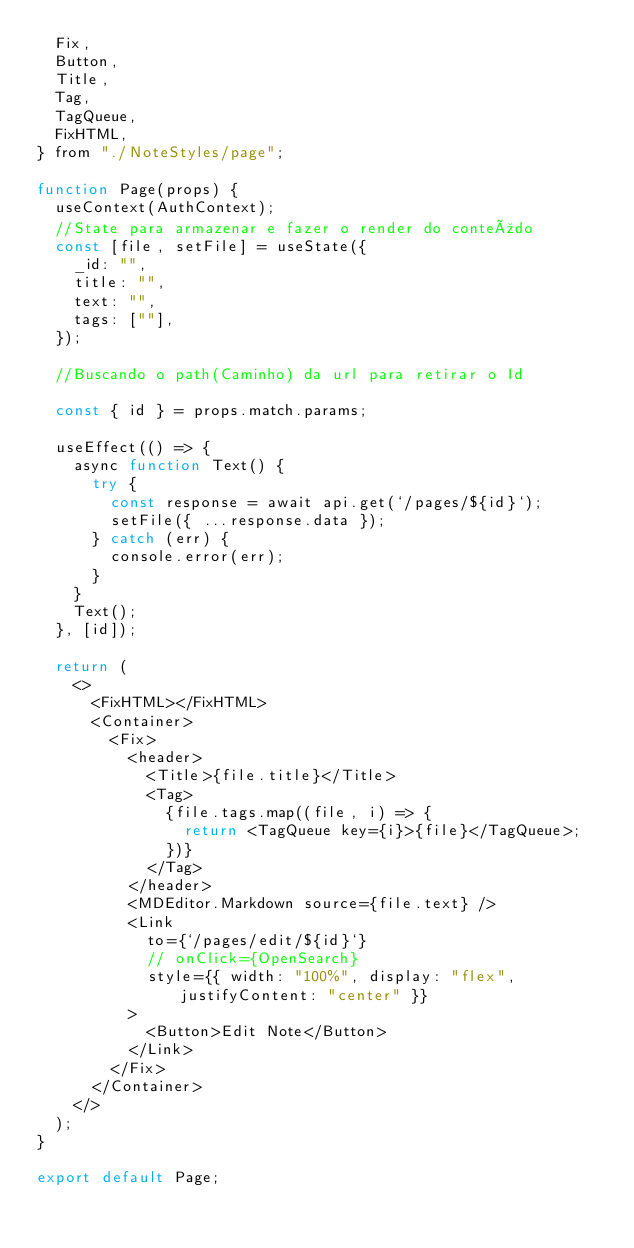Convert code to text. <code><loc_0><loc_0><loc_500><loc_500><_JavaScript_>  Fix,
  Button,
  Title,
  Tag,
  TagQueue,
  FixHTML,
} from "./NoteStyles/page";

function Page(props) {
  useContext(AuthContext);
  //State para armazenar e fazer o render do conteúdo
  const [file, setFile] = useState({
    _id: "",
    title: "",
    text: "",
    tags: [""],
  });

  //Buscando o path(Caminho) da url para retirar o Id

  const { id } = props.match.params;

  useEffect(() => {
    async function Text() {
      try {
        const response = await api.get(`/pages/${id}`);
        setFile({ ...response.data });
      } catch (err) {
        console.error(err);
      }
    }
    Text();
  }, [id]);

  return (
    <>
      <FixHTML></FixHTML>
      <Container>
        <Fix>
          <header>
            <Title>{file.title}</Title>
            <Tag>
              {file.tags.map((file, i) => {
                return <TagQueue key={i}>{file}</TagQueue>;
              })}
            </Tag>
          </header>
          <MDEditor.Markdown source={file.text} />
          <Link
            to={`/pages/edit/${id}`}
            // onClick={OpenSearch}
            style={{ width: "100%", display: "flex", justifyContent: "center" }}
          >
            <Button>Edit Note</Button>
          </Link>
        </Fix>
      </Container>
    </>
  );
}

export default Page;
</code> 